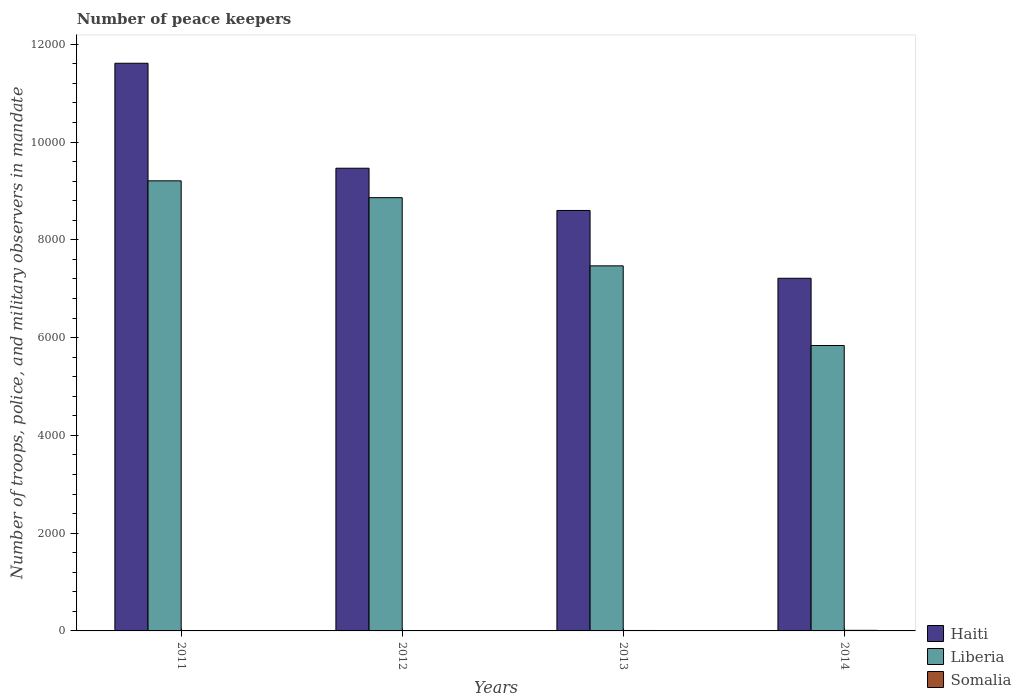How many different coloured bars are there?
Keep it short and to the point. 3. Are the number of bars on each tick of the X-axis equal?
Offer a very short reply. Yes. How many bars are there on the 2nd tick from the left?
Your response must be concise. 3. How many bars are there on the 4th tick from the right?
Offer a terse response. 3. What is the number of peace keepers in in Haiti in 2013?
Your answer should be compact. 8600. Across all years, what is the maximum number of peace keepers in in Liberia?
Your answer should be compact. 9206. Across all years, what is the minimum number of peace keepers in in Haiti?
Make the answer very short. 7213. What is the total number of peace keepers in in Somalia in the graph?
Offer a very short reply. 30. What is the difference between the number of peace keepers in in Haiti in 2014 and the number of peace keepers in in Somalia in 2013?
Provide a succinct answer. 7204. What is the average number of peace keepers in in Somalia per year?
Make the answer very short. 7.5. In the year 2014, what is the difference between the number of peace keepers in in Somalia and number of peace keepers in in Liberia?
Your answer should be very brief. -5826. What is the ratio of the number of peace keepers in in Haiti in 2011 to that in 2012?
Ensure brevity in your answer.  1.23. Is the number of peace keepers in in Liberia in 2012 less than that in 2014?
Provide a succinct answer. No. Is the difference between the number of peace keepers in in Somalia in 2011 and 2014 greater than the difference between the number of peace keepers in in Liberia in 2011 and 2014?
Ensure brevity in your answer.  No. What is the difference between the highest and the second highest number of peace keepers in in Somalia?
Give a very brief answer. 3. What is the difference between the highest and the lowest number of peace keepers in in Liberia?
Provide a short and direct response. 3368. In how many years, is the number of peace keepers in in Liberia greater than the average number of peace keepers in in Liberia taken over all years?
Your answer should be very brief. 2. What does the 1st bar from the left in 2012 represents?
Give a very brief answer. Haiti. What does the 3rd bar from the right in 2012 represents?
Keep it short and to the point. Haiti. How many bars are there?
Provide a short and direct response. 12. How many years are there in the graph?
Your answer should be compact. 4. What is the difference between two consecutive major ticks on the Y-axis?
Your response must be concise. 2000. Are the values on the major ticks of Y-axis written in scientific E-notation?
Make the answer very short. No. Does the graph contain any zero values?
Your answer should be compact. No. Does the graph contain grids?
Give a very brief answer. No. Where does the legend appear in the graph?
Make the answer very short. Bottom right. How are the legend labels stacked?
Ensure brevity in your answer.  Vertical. What is the title of the graph?
Give a very brief answer. Number of peace keepers. Does "Albania" appear as one of the legend labels in the graph?
Your answer should be very brief. No. What is the label or title of the X-axis?
Provide a succinct answer. Years. What is the label or title of the Y-axis?
Your response must be concise. Number of troops, police, and military observers in mandate. What is the Number of troops, police, and military observers in mandate of Haiti in 2011?
Your response must be concise. 1.16e+04. What is the Number of troops, police, and military observers in mandate in Liberia in 2011?
Your response must be concise. 9206. What is the Number of troops, police, and military observers in mandate in Somalia in 2011?
Ensure brevity in your answer.  6. What is the Number of troops, police, and military observers in mandate in Haiti in 2012?
Your answer should be compact. 9464. What is the Number of troops, police, and military observers in mandate in Liberia in 2012?
Your answer should be very brief. 8862. What is the Number of troops, police, and military observers in mandate in Somalia in 2012?
Ensure brevity in your answer.  3. What is the Number of troops, police, and military observers in mandate in Haiti in 2013?
Keep it short and to the point. 8600. What is the Number of troops, police, and military observers in mandate of Liberia in 2013?
Offer a very short reply. 7467. What is the Number of troops, police, and military observers in mandate of Haiti in 2014?
Keep it short and to the point. 7213. What is the Number of troops, police, and military observers in mandate in Liberia in 2014?
Your answer should be very brief. 5838. What is the Number of troops, police, and military observers in mandate in Somalia in 2014?
Your answer should be compact. 12. Across all years, what is the maximum Number of troops, police, and military observers in mandate in Haiti?
Make the answer very short. 1.16e+04. Across all years, what is the maximum Number of troops, police, and military observers in mandate of Liberia?
Offer a very short reply. 9206. Across all years, what is the maximum Number of troops, police, and military observers in mandate in Somalia?
Offer a terse response. 12. Across all years, what is the minimum Number of troops, police, and military observers in mandate in Haiti?
Make the answer very short. 7213. Across all years, what is the minimum Number of troops, police, and military observers in mandate in Liberia?
Your response must be concise. 5838. What is the total Number of troops, police, and military observers in mandate of Haiti in the graph?
Provide a succinct answer. 3.69e+04. What is the total Number of troops, police, and military observers in mandate of Liberia in the graph?
Offer a very short reply. 3.14e+04. What is the total Number of troops, police, and military observers in mandate of Somalia in the graph?
Provide a succinct answer. 30. What is the difference between the Number of troops, police, and military observers in mandate of Haiti in 2011 and that in 2012?
Make the answer very short. 2147. What is the difference between the Number of troops, police, and military observers in mandate in Liberia in 2011 and that in 2012?
Keep it short and to the point. 344. What is the difference between the Number of troops, police, and military observers in mandate in Haiti in 2011 and that in 2013?
Keep it short and to the point. 3011. What is the difference between the Number of troops, police, and military observers in mandate in Liberia in 2011 and that in 2013?
Keep it short and to the point. 1739. What is the difference between the Number of troops, police, and military observers in mandate of Haiti in 2011 and that in 2014?
Provide a succinct answer. 4398. What is the difference between the Number of troops, police, and military observers in mandate of Liberia in 2011 and that in 2014?
Give a very brief answer. 3368. What is the difference between the Number of troops, police, and military observers in mandate of Somalia in 2011 and that in 2014?
Provide a short and direct response. -6. What is the difference between the Number of troops, police, and military observers in mandate in Haiti in 2012 and that in 2013?
Your answer should be compact. 864. What is the difference between the Number of troops, police, and military observers in mandate of Liberia in 2012 and that in 2013?
Offer a very short reply. 1395. What is the difference between the Number of troops, police, and military observers in mandate of Haiti in 2012 and that in 2014?
Provide a succinct answer. 2251. What is the difference between the Number of troops, police, and military observers in mandate in Liberia in 2012 and that in 2014?
Provide a succinct answer. 3024. What is the difference between the Number of troops, police, and military observers in mandate in Somalia in 2012 and that in 2014?
Offer a terse response. -9. What is the difference between the Number of troops, police, and military observers in mandate in Haiti in 2013 and that in 2014?
Your answer should be very brief. 1387. What is the difference between the Number of troops, police, and military observers in mandate of Liberia in 2013 and that in 2014?
Your answer should be compact. 1629. What is the difference between the Number of troops, police, and military observers in mandate of Somalia in 2013 and that in 2014?
Provide a short and direct response. -3. What is the difference between the Number of troops, police, and military observers in mandate of Haiti in 2011 and the Number of troops, police, and military observers in mandate of Liberia in 2012?
Ensure brevity in your answer.  2749. What is the difference between the Number of troops, police, and military observers in mandate of Haiti in 2011 and the Number of troops, police, and military observers in mandate of Somalia in 2012?
Offer a terse response. 1.16e+04. What is the difference between the Number of troops, police, and military observers in mandate of Liberia in 2011 and the Number of troops, police, and military observers in mandate of Somalia in 2012?
Give a very brief answer. 9203. What is the difference between the Number of troops, police, and military observers in mandate of Haiti in 2011 and the Number of troops, police, and military observers in mandate of Liberia in 2013?
Your response must be concise. 4144. What is the difference between the Number of troops, police, and military observers in mandate in Haiti in 2011 and the Number of troops, police, and military observers in mandate in Somalia in 2013?
Your answer should be very brief. 1.16e+04. What is the difference between the Number of troops, police, and military observers in mandate of Liberia in 2011 and the Number of troops, police, and military observers in mandate of Somalia in 2013?
Ensure brevity in your answer.  9197. What is the difference between the Number of troops, police, and military observers in mandate in Haiti in 2011 and the Number of troops, police, and military observers in mandate in Liberia in 2014?
Provide a short and direct response. 5773. What is the difference between the Number of troops, police, and military observers in mandate of Haiti in 2011 and the Number of troops, police, and military observers in mandate of Somalia in 2014?
Ensure brevity in your answer.  1.16e+04. What is the difference between the Number of troops, police, and military observers in mandate in Liberia in 2011 and the Number of troops, police, and military observers in mandate in Somalia in 2014?
Offer a very short reply. 9194. What is the difference between the Number of troops, police, and military observers in mandate in Haiti in 2012 and the Number of troops, police, and military observers in mandate in Liberia in 2013?
Make the answer very short. 1997. What is the difference between the Number of troops, police, and military observers in mandate in Haiti in 2012 and the Number of troops, police, and military observers in mandate in Somalia in 2013?
Your answer should be very brief. 9455. What is the difference between the Number of troops, police, and military observers in mandate in Liberia in 2012 and the Number of troops, police, and military observers in mandate in Somalia in 2013?
Your response must be concise. 8853. What is the difference between the Number of troops, police, and military observers in mandate of Haiti in 2012 and the Number of troops, police, and military observers in mandate of Liberia in 2014?
Your answer should be very brief. 3626. What is the difference between the Number of troops, police, and military observers in mandate of Haiti in 2012 and the Number of troops, police, and military observers in mandate of Somalia in 2014?
Give a very brief answer. 9452. What is the difference between the Number of troops, police, and military observers in mandate in Liberia in 2012 and the Number of troops, police, and military observers in mandate in Somalia in 2014?
Your answer should be compact. 8850. What is the difference between the Number of troops, police, and military observers in mandate in Haiti in 2013 and the Number of troops, police, and military observers in mandate in Liberia in 2014?
Your response must be concise. 2762. What is the difference between the Number of troops, police, and military observers in mandate in Haiti in 2013 and the Number of troops, police, and military observers in mandate in Somalia in 2014?
Make the answer very short. 8588. What is the difference between the Number of troops, police, and military observers in mandate of Liberia in 2013 and the Number of troops, police, and military observers in mandate of Somalia in 2014?
Provide a succinct answer. 7455. What is the average Number of troops, police, and military observers in mandate in Haiti per year?
Your answer should be very brief. 9222. What is the average Number of troops, police, and military observers in mandate in Liberia per year?
Your response must be concise. 7843.25. What is the average Number of troops, police, and military observers in mandate in Somalia per year?
Make the answer very short. 7.5. In the year 2011, what is the difference between the Number of troops, police, and military observers in mandate in Haiti and Number of troops, police, and military observers in mandate in Liberia?
Provide a succinct answer. 2405. In the year 2011, what is the difference between the Number of troops, police, and military observers in mandate in Haiti and Number of troops, police, and military observers in mandate in Somalia?
Make the answer very short. 1.16e+04. In the year 2011, what is the difference between the Number of troops, police, and military observers in mandate in Liberia and Number of troops, police, and military observers in mandate in Somalia?
Make the answer very short. 9200. In the year 2012, what is the difference between the Number of troops, police, and military observers in mandate in Haiti and Number of troops, police, and military observers in mandate in Liberia?
Your answer should be very brief. 602. In the year 2012, what is the difference between the Number of troops, police, and military observers in mandate of Haiti and Number of troops, police, and military observers in mandate of Somalia?
Keep it short and to the point. 9461. In the year 2012, what is the difference between the Number of troops, police, and military observers in mandate of Liberia and Number of troops, police, and military observers in mandate of Somalia?
Make the answer very short. 8859. In the year 2013, what is the difference between the Number of troops, police, and military observers in mandate of Haiti and Number of troops, police, and military observers in mandate of Liberia?
Make the answer very short. 1133. In the year 2013, what is the difference between the Number of troops, police, and military observers in mandate in Haiti and Number of troops, police, and military observers in mandate in Somalia?
Your answer should be compact. 8591. In the year 2013, what is the difference between the Number of troops, police, and military observers in mandate of Liberia and Number of troops, police, and military observers in mandate of Somalia?
Provide a short and direct response. 7458. In the year 2014, what is the difference between the Number of troops, police, and military observers in mandate of Haiti and Number of troops, police, and military observers in mandate of Liberia?
Your answer should be compact. 1375. In the year 2014, what is the difference between the Number of troops, police, and military observers in mandate of Haiti and Number of troops, police, and military observers in mandate of Somalia?
Keep it short and to the point. 7201. In the year 2014, what is the difference between the Number of troops, police, and military observers in mandate in Liberia and Number of troops, police, and military observers in mandate in Somalia?
Your response must be concise. 5826. What is the ratio of the Number of troops, police, and military observers in mandate of Haiti in 2011 to that in 2012?
Ensure brevity in your answer.  1.23. What is the ratio of the Number of troops, police, and military observers in mandate of Liberia in 2011 to that in 2012?
Give a very brief answer. 1.04. What is the ratio of the Number of troops, police, and military observers in mandate in Haiti in 2011 to that in 2013?
Make the answer very short. 1.35. What is the ratio of the Number of troops, police, and military observers in mandate of Liberia in 2011 to that in 2013?
Provide a short and direct response. 1.23. What is the ratio of the Number of troops, police, and military observers in mandate in Somalia in 2011 to that in 2013?
Ensure brevity in your answer.  0.67. What is the ratio of the Number of troops, police, and military observers in mandate in Haiti in 2011 to that in 2014?
Keep it short and to the point. 1.61. What is the ratio of the Number of troops, police, and military observers in mandate of Liberia in 2011 to that in 2014?
Keep it short and to the point. 1.58. What is the ratio of the Number of troops, police, and military observers in mandate in Haiti in 2012 to that in 2013?
Your response must be concise. 1.1. What is the ratio of the Number of troops, police, and military observers in mandate in Liberia in 2012 to that in 2013?
Keep it short and to the point. 1.19. What is the ratio of the Number of troops, police, and military observers in mandate in Somalia in 2012 to that in 2013?
Provide a succinct answer. 0.33. What is the ratio of the Number of troops, police, and military observers in mandate of Haiti in 2012 to that in 2014?
Your response must be concise. 1.31. What is the ratio of the Number of troops, police, and military observers in mandate of Liberia in 2012 to that in 2014?
Offer a terse response. 1.52. What is the ratio of the Number of troops, police, and military observers in mandate in Haiti in 2013 to that in 2014?
Your answer should be compact. 1.19. What is the ratio of the Number of troops, police, and military observers in mandate in Liberia in 2013 to that in 2014?
Provide a short and direct response. 1.28. What is the difference between the highest and the second highest Number of troops, police, and military observers in mandate in Haiti?
Your response must be concise. 2147. What is the difference between the highest and the second highest Number of troops, police, and military observers in mandate of Liberia?
Offer a very short reply. 344. What is the difference between the highest and the lowest Number of troops, police, and military observers in mandate of Haiti?
Your answer should be compact. 4398. What is the difference between the highest and the lowest Number of troops, police, and military observers in mandate of Liberia?
Make the answer very short. 3368. What is the difference between the highest and the lowest Number of troops, police, and military observers in mandate in Somalia?
Keep it short and to the point. 9. 